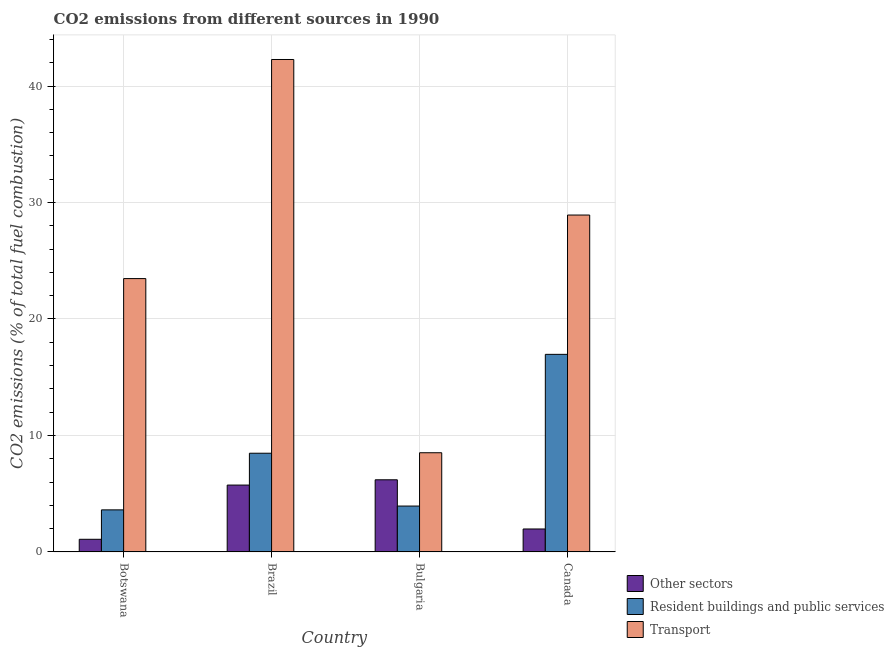Are the number of bars on each tick of the X-axis equal?
Give a very brief answer. Yes. How many bars are there on the 1st tick from the left?
Your answer should be very brief. 3. How many bars are there on the 2nd tick from the right?
Give a very brief answer. 3. What is the label of the 4th group of bars from the left?
Give a very brief answer. Canada. What is the percentage of co2 emissions from transport in Canada?
Your answer should be compact. 28.92. Across all countries, what is the maximum percentage of co2 emissions from resident buildings and public services?
Your answer should be very brief. 16.96. Across all countries, what is the minimum percentage of co2 emissions from resident buildings and public services?
Give a very brief answer. 3.61. In which country was the percentage of co2 emissions from resident buildings and public services minimum?
Keep it short and to the point. Botswana. What is the total percentage of co2 emissions from transport in the graph?
Ensure brevity in your answer.  103.18. What is the difference between the percentage of co2 emissions from other sectors in Bulgaria and that in Canada?
Make the answer very short. 4.22. What is the difference between the percentage of co2 emissions from transport in Canada and the percentage of co2 emissions from resident buildings and public services in Botswana?
Make the answer very short. 25.31. What is the average percentage of co2 emissions from transport per country?
Provide a succinct answer. 25.79. What is the difference between the percentage of co2 emissions from resident buildings and public services and percentage of co2 emissions from transport in Brazil?
Keep it short and to the point. -33.8. In how many countries, is the percentage of co2 emissions from resident buildings and public services greater than 2 %?
Provide a short and direct response. 4. What is the ratio of the percentage of co2 emissions from transport in Brazil to that in Canada?
Keep it short and to the point. 1.46. Is the difference between the percentage of co2 emissions from resident buildings and public services in Bulgaria and Canada greater than the difference between the percentage of co2 emissions from other sectors in Bulgaria and Canada?
Keep it short and to the point. No. What is the difference between the highest and the second highest percentage of co2 emissions from resident buildings and public services?
Your answer should be very brief. 8.49. What is the difference between the highest and the lowest percentage of co2 emissions from resident buildings and public services?
Your answer should be compact. 13.35. What does the 1st bar from the left in Brazil represents?
Offer a very short reply. Other sectors. What does the 3rd bar from the right in Bulgaria represents?
Give a very brief answer. Other sectors. How many bars are there?
Provide a succinct answer. 12. How many countries are there in the graph?
Give a very brief answer. 4. What is the difference between two consecutive major ticks on the Y-axis?
Provide a short and direct response. 10. Are the values on the major ticks of Y-axis written in scientific E-notation?
Offer a very short reply. No. Does the graph contain any zero values?
Make the answer very short. No. What is the title of the graph?
Your answer should be very brief. CO2 emissions from different sources in 1990. What is the label or title of the X-axis?
Provide a succinct answer. Country. What is the label or title of the Y-axis?
Offer a very short reply. CO2 emissions (% of total fuel combustion). What is the CO2 emissions (% of total fuel combustion) in Other sectors in Botswana?
Give a very brief answer. 1.08. What is the CO2 emissions (% of total fuel combustion) in Resident buildings and public services in Botswana?
Your answer should be very brief. 3.61. What is the CO2 emissions (% of total fuel combustion) in Transport in Botswana?
Offer a very short reply. 23.47. What is the CO2 emissions (% of total fuel combustion) in Other sectors in Brazil?
Your response must be concise. 5.74. What is the CO2 emissions (% of total fuel combustion) of Resident buildings and public services in Brazil?
Your answer should be very brief. 8.47. What is the CO2 emissions (% of total fuel combustion) of Transport in Brazil?
Provide a short and direct response. 42.28. What is the CO2 emissions (% of total fuel combustion) in Other sectors in Bulgaria?
Your answer should be compact. 6.19. What is the CO2 emissions (% of total fuel combustion) in Resident buildings and public services in Bulgaria?
Provide a succinct answer. 3.94. What is the CO2 emissions (% of total fuel combustion) of Transport in Bulgaria?
Offer a very short reply. 8.51. What is the CO2 emissions (% of total fuel combustion) of Other sectors in Canada?
Provide a succinct answer. 1.97. What is the CO2 emissions (% of total fuel combustion) in Resident buildings and public services in Canada?
Offer a terse response. 16.96. What is the CO2 emissions (% of total fuel combustion) of Transport in Canada?
Keep it short and to the point. 28.92. Across all countries, what is the maximum CO2 emissions (% of total fuel combustion) of Other sectors?
Make the answer very short. 6.19. Across all countries, what is the maximum CO2 emissions (% of total fuel combustion) of Resident buildings and public services?
Keep it short and to the point. 16.96. Across all countries, what is the maximum CO2 emissions (% of total fuel combustion) of Transport?
Make the answer very short. 42.28. Across all countries, what is the minimum CO2 emissions (% of total fuel combustion) of Other sectors?
Your answer should be very brief. 1.08. Across all countries, what is the minimum CO2 emissions (% of total fuel combustion) of Resident buildings and public services?
Keep it short and to the point. 3.61. Across all countries, what is the minimum CO2 emissions (% of total fuel combustion) in Transport?
Offer a terse response. 8.51. What is the total CO2 emissions (% of total fuel combustion) of Other sectors in the graph?
Give a very brief answer. 14.98. What is the total CO2 emissions (% of total fuel combustion) in Resident buildings and public services in the graph?
Provide a succinct answer. 32.98. What is the total CO2 emissions (% of total fuel combustion) in Transport in the graph?
Ensure brevity in your answer.  103.18. What is the difference between the CO2 emissions (% of total fuel combustion) of Other sectors in Botswana and that in Brazil?
Make the answer very short. -4.66. What is the difference between the CO2 emissions (% of total fuel combustion) of Resident buildings and public services in Botswana and that in Brazil?
Ensure brevity in your answer.  -4.86. What is the difference between the CO2 emissions (% of total fuel combustion) of Transport in Botswana and that in Brazil?
Your answer should be very brief. -18.81. What is the difference between the CO2 emissions (% of total fuel combustion) of Other sectors in Botswana and that in Bulgaria?
Your response must be concise. -5.11. What is the difference between the CO2 emissions (% of total fuel combustion) of Resident buildings and public services in Botswana and that in Bulgaria?
Offer a terse response. -0.33. What is the difference between the CO2 emissions (% of total fuel combustion) in Transport in Botswana and that in Bulgaria?
Your answer should be compact. 14.95. What is the difference between the CO2 emissions (% of total fuel combustion) in Other sectors in Botswana and that in Canada?
Make the answer very short. -0.89. What is the difference between the CO2 emissions (% of total fuel combustion) in Resident buildings and public services in Botswana and that in Canada?
Offer a terse response. -13.35. What is the difference between the CO2 emissions (% of total fuel combustion) in Transport in Botswana and that in Canada?
Your response must be concise. -5.46. What is the difference between the CO2 emissions (% of total fuel combustion) of Other sectors in Brazil and that in Bulgaria?
Keep it short and to the point. -0.45. What is the difference between the CO2 emissions (% of total fuel combustion) of Resident buildings and public services in Brazil and that in Bulgaria?
Your response must be concise. 4.54. What is the difference between the CO2 emissions (% of total fuel combustion) in Transport in Brazil and that in Bulgaria?
Your response must be concise. 33.76. What is the difference between the CO2 emissions (% of total fuel combustion) in Other sectors in Brazil and that in Canada?
Give a very brief answer. 3.77. What is the difference between the CO2 emissions (% of total fuel combustion) of Resident buildings and public services in Brazil and that in Canada?
Offer a terse response. -8.49. What is the difference between the CO2 emissions (% of total fuel combustion) in Transport in Brazil and that in Canada?
Your answer should be compact. 13.35. What is the difference between the CO2 emissions (% of total fuel combustion) in Other sectors in Bulgaria and that in Canada?
Your answer should be very brief. 4.22. What is the difference between the CO2 emissions (% of total fuel combustion) of Resident buildings and public services in Bulgaria and that in Canada?
Your response must be concise. -13.03. What is the difference between the CO2 emissions (% of total fuel combustion) in Transport in Bulgaria and that in Canada?
Offer a very short reply. -20.41. What is the difference between the CO2 emissions (% of total fuel combustion) of Other sectors in Botswana and the CO2 emissions (% of total fuel combustion) of Resident buildings and public services in Brazil?
Your answer should be compact. -7.39. What is the difference between the CO2 emissions (% of total fuel combustion) of Other sectors in Botswana and the CO2 emissions (% of total fuel combustion) of Transport in Brazil?
Your response must be concise. -41.19. What is the difference between the CO2 emissions (% of total fuel combustion) of Resident buildings and public services in Botswana and the CO2 emissions (% of total fuel combustion) of Transport in Brazil?
Your answer should be very brief. -38.67. What is the difference between the CO2 emissions (% of total fuel combustion) in Other sectors in Botswana and the CO2 emissions (% of total fuel combustion) in Resident buildings and public services in Bulgaria?
Offer a terse response. -2.85. What is the difference between the CO2 emissions (% of total fuel combustion) in Other sectors in Botswana and the CO2 emissions (% of total fuel combustion) in Transport in Bulgaria?
Your answer should be very brief. -7.43. What is the difference between the CO2 emissions (% of total fuel combustion) of Resident buildings and public services in Botswana and the CO2 emissions (% of total fuel combustion) of Transport in Bulgaria?
Keep it short and to the point. -4.9. What is the difference between the CO2 emissions (% of total fuel combustion) of Other sectors in Botswana and the CO2 emissions (% of total fuel combustion) of Resident buildings and public services in Canada?
Provide a succinct answer. -15.88. What is the difference between the CO2 emissions (% of total fuel combustion) in Other sectors in Botswana and the CO2 emissions (% of total fuel combustion) in Transport in Canada?
Your answer should be compact. -27.84. What is the difference between the CO2 emissions (% of total fuel combustion) of Resident buildings and public services in Botswana and the CO2 emissions (% of total fuel combustion) of Transport in Canada?
Your answer should be compact. -25.31. What is the difference between the CO2 emissions (% of total fuel combustion) in Other sectors in Brazil and the CO2 emissions (% of total fuel combustion) in Resident buildings and public services in Bulgaria?
Your answer should be compact. 1.8. What is the difference between the CO2 emissions (% of total fuel combustion) of Other sectors in Brazil and the CO2 emissions (% of total fuel combustion) of Transport in Bulgaria?
Your answer should be compact. -2.77. What is the difference between the CO2 emissions (% of total fuel combustion) of Resident buildings and public services in Brazil and the CO2 emissions (% of total fuel combustion) of Transport in Bulgaria?
Give a very brief answer. -0.04. What is the difference between the CO2 emissions (% of total fuel combustion) of Other sectors in Brazil and the CO2 emissions (% of total fuel combustion) of Resident buildings and public services in Canada?
Keep it short and to the point. -11.22. What is the difference between the CO2 emissions (% of total fuel combustion) in Other sectors in Brazil and the CO2 emissions (% of total fuel combustion) in Transport in Canada?
Provide a short and direct response. -23.18. What is the difference between the CO2 emissions (% of total fuel combustion) of Resident buildings and public services in Brazil and the CO2 emissions (% of total fuel combustion) of Transport in Canada?
Keep it short and to the point. -20.45. What is the difference between the CO2 emissions (% of total fuel combustion) in Other sectors in Bulgaria and the CO2 emissions (% of total fuel combustion) in Resident buildings and public services in Canada?
Offer a very short reply. -10.77. What is the difference between the CO2 emissions (% of total fuel combustion) in Other sectors in Bulgaria and the CO2 emissions (% of total fuel combustion) in Transport in Canada?
Your answer should be compact. -22.73. What is the difference between the CO2 emissions (% of total fuel combustion) in Resident buildings and public services in Bulgaria and the CO2 emissions (% of total fuel combustion) in Transport in Canada?
Provide a short and direct response. -24.98. What is the average CO2 emissions (% of total fuel combustion) in Other sectors per country?
Give a very brief answer. 3.75. What is the average CO2 emissions (% of total fuel combustion) of Resident buildings and public services per country?
Give a very brief answer. 8.25. What is the average CO2 emissions (% of total fuel combustion) of Transport per country?
Offer a very short reply. 25.79. What is the difference between the CO2 emissions (% of total fuel combustion) in Other sectors and CO2 emissions (% of total fuel combustion) in Resident buildings and public services in Botswana?
Provide a short and direct response. -2.53. What is the difference between the CO2 emissions (% of total fuel combustion) of Other sectors and CO2 emissions (% of total fuel combustion) of Transport in Botswana?
Your answer should be very brief. -22.38. What is the difference between the CO2 emissions (% of total fuel combustion) of Resident buildings and public services and CO2 emissions (% of total fuel combustion) of Transport in Botswana?
Give a very brief answer. -19.86. What is the difference between the CO2 emissions (% of total fuel combustion) of Other sectors and CO2 emissions (% of total fuel combustion) of Resident buildings and public services in Brazil?
Your answer should be very brief. -2.73. What is the difference between the CO2 emissions (% of total fuel combustion) of Other sectors and CO2 emissions (% of total fuel combustion) of Transport in Brazil?
Offer a very short reply. -36.54. What is the difference between the CO2 emissions (% of total fuel combustion) of Resident buildings and public services and CO2 emissions (% of total fuel combustion) of Transport in Brazil?
Provide a short and direct response. -33.8. What is the difference between the CO2 emissions (% of total fuel combustion) of Other sectors and CO2 emissions (% of total fuel combustion) of Resident buildings and public services in Bulgaria?
Offer a terse response. 2.26. What is the difference between the CO2 emissions (% of total fuel combustion) in Other sectors and CO2 emissions (% of total fuel combustion) in Transport in Bulgaria?
Ensure brevity in your answer.  -2.32. What is the difference between the CO2 emissions (% of total fuel combustion) in Resident buildings and public services and CO2 emissions (% of total fuel combustion) in Transport in Bulgaria?
Provide a short and direct response. -4.58. What is the difference between the CO2 emissions (% of total fuel combustion) of Other sectors and CO2 emissions (% of total fuel combustion) of Resident buildings and public services in Canada?
Provide a succinct answer. -14.99. What is the difference between the CO2 emissions (% of total fuel combustion) of Other sectors and CO2 emissions (% of total fuel combustion) of Transport in Canada?
Give a very brief answer. -26.95. What is the difference between the CO2 emissions (% of total fuel combustion) of Resident buildings and public services and CO2 emissions (% of total fuel combustion) of Transport in Canada?
Ensure brevity in your answer.  -11.96. What is the ratio of the CO2 emissions (% of total fuel combustion) in Other sectors in Botswana to that in Brazil?
Your response must be concise. 0.19. What is the ratio of the CO2 emissions (% of total fuel combustion) of Resident buildings and public services in Botswana to that in Brazil?
Provide a succinct answer. 0.43. What is the ratio of the CO2 emissions (% of total fuel combustion) in Transport in Botswana to that in Brazil?
Your answer should be compact. 0.56. What is the ratio of the CO2 emissions (% of total fuel combustion) of Other sectors in Botswana to that in Bulgaria?
Keep it short and to the point. 0.17. What is the ratio of the CO2 emissions (% of total fuel combustion) of Resident buildings and public services in Botswana to that in Bulgaria?
Offer a very short reply. 0.92. What is the ratio of the CO2 emissions (% of total fuel combustion) of Transport in Botswana to that in Bulgaria?
Your response must be concise. 2.76. What is the ratio of the CO2 emissions (% of total fuel combustion) of Other sectors in Botswana to that in Canada?
Give a very brief answer. 0.55. What is the ratio of the CO2 emissions (% of total fuel combustion) of Resident buildings and public services in Botswana to that in Canada?
Your response must be concise. 0.21. What is the ratio of the CO2 emissions (% of total fuel combustion) of Transport in Botswana to that in Canada?
Your response must be concise. 0.81. What is the ratio of the CO2 emissions (% of total fuel combustion) of Other sectors in Brazil to that in Bulgaria?
Provide a succinct answer. 0.93. What is the ratio of the CO2 emissions (% of total fuel combustion) of Resident buildings and public services in Brazil to that in Bulgaria?
Make the answer very short. 2.15. What is the ratio of the CO2 emissions (% of total fuel combustion) in Transport in Brazil to that in Bulgaria?
Make the answer very short. 4.97. What is the ratio of the CO2 emissions (% of total fuel combustion) in Other sectors in Brazil to that in Canada?
Provide a short and direct response. 2.91. What is the ratio of the CO2 emissions (% of total fuel combustion) of Resident buildings and public services in Brazil to that in Canada?
Ensure brevity in your answer.  0.5. What is the ratio of the CO2 emissions (% of total fuel combustion) in Transport in Brazil to that in Canada?
Ensure brevity in your answer.  1.46. What is the ratio of the CO2 emissions (% of total fuel combustion) in Other sectors in Bulgaria to that in Canada?
Offer a very short reply. 3.15. What is the ratio of the CO2 emissions (% of total fuel combustion) in Resident buildings and public services in Bulgaria to that in Canada?
Your response must be concise. 0.23. What is the ratio of the CO2 emissions (% of total fuel combustion) of Transport in Bulgaria to that in Canada?
Your response must be concise. 0.29. What is the difference between the highest and the second highest CO2 emissions (% of total fuel combustion) of Other sectors?
Ensure brevity in your answer.  0.45. What is the difference between the highest and the second highest CO2 emissions (% of total fuel combustion) of Resident buildings and public services?
Offer a very short reply. 8.49. What is the difference between the highest and the second highest CO2 emissions (% of total fuel combustion) in Transport?
Your response must be concise. 13.35. What is the difference between the highest and the lowest CO2 emissions (% of total fuel combustion) of Other sectors?
Ensure brevity in your answer.  5.11. What is the difference between the highest and the lowest CO2 emissions (% of total fuel combustion) in Resident buildings and public services?
Your answer should be compact. 13.35. What is the difference between the highest and the lowest CO2 emissions (% of total fuel combustion) in Transport?
Give a very brief answer. 33.76. 